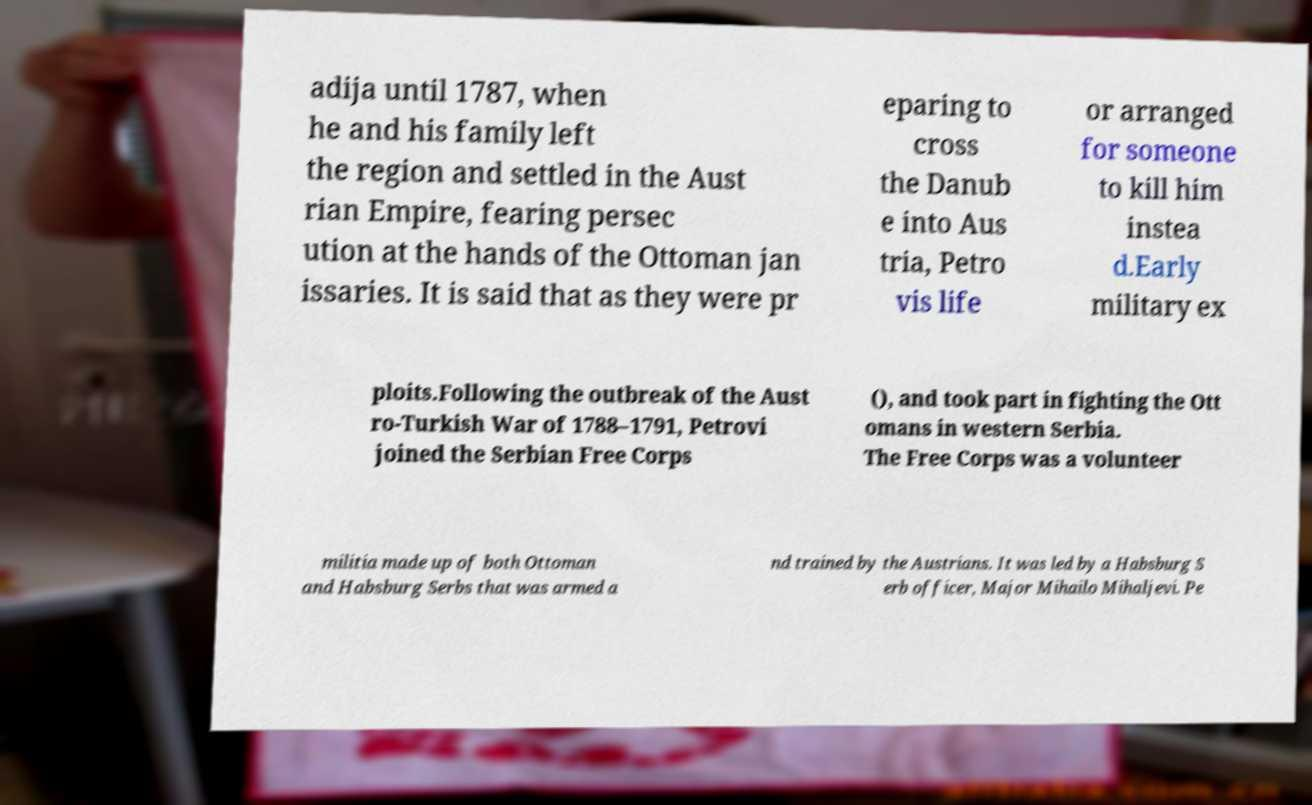Please identify and transcribe the text found in this image. adija until 1787, when he and his family left the region and settled in the Aust rian Empire, fearing persec ution at the hands of the Ottoman jan issaries. It is said that as they were pr eparing to cross the Danub e into Aus tria, Petro vis life or arranged for someone to kill him instea d.Early military ex ploits.Following the outbreak of the Aust ro-Turkish War of 1788–1791, Petrovi joined the Serbian Free Corps (), and took part in fighting the Ott omans in western Serbia. The Free Corps was a volunteer militia made up of both Ottoman and Habsburg Serbs that was armed a nd trained by the Austrians. It was led by a Habsburg S erb officer, Major Mihailo Mihaljevi. Pe 